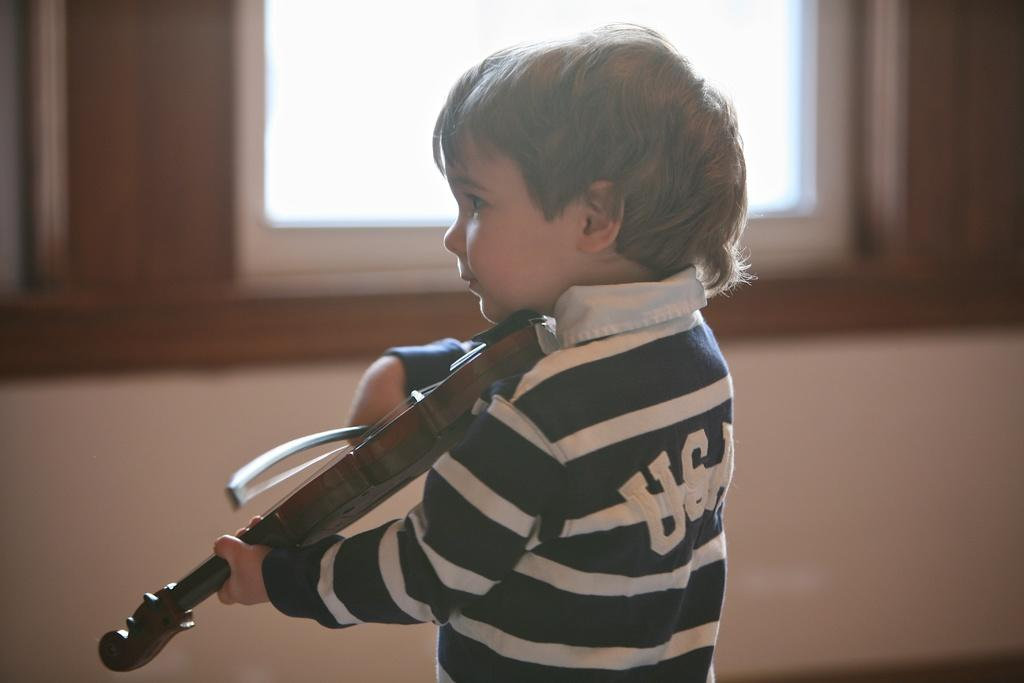What is the main subject of the image? There is a small boy in the center of the image. What is the boy holding in the image? The boy is holding a guitar. Can you describe any architectural features in the image? There is a window at the top side of the image. What type of slope can be seen in the image? There is no slope present in the image. What kind of feast is being prepared in the image? There is no feast or preparation for a feast visible in the image. 